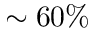<formula> <loc_0><loc_0><loc_500><loc_500>\sim 6 0 \%</formula> 